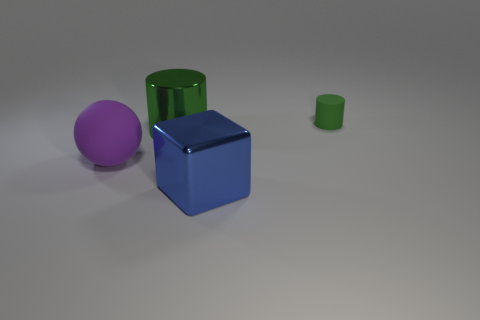Are there any other things that have the same size as the green matte cylinder?
Provide a short and direct response. No. How many things are tiny gray blocks or objects that are behind the sphere?
Provide a succinct answer. 2. There is a large object that is left of the large object behind the big purple rubber sphere; what number of big metallic cylinders are behind it?
Your answer should be very brief. 1. There is a cylinder that is the same material as the large ball; what color is it?
Offer a terse response. Green. Does the green thing that is on the left side of the matte cylinder have the same size as the small cylinder?
Your answer should be compact. No. How many things are large matte balls or large blue objects?
Provide a succinct answer. 2. What material is the green cylinder that is to the left of the object that is to the right of the block in front of the small rubber object made of?
Your answer should be very brief. Metal. There is a object in front of the large matte object; what material is it?
Give a very brief answer. Metal. Is there a green thing of the same size as the blue block?
Keep it short and to the point. Yes. There is a matte thing that is behind the large matte object; is its color the same as the big shiny cylinder?
Ensure brevity in your answer.  Yes. 